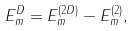Convert formula to latex. <formula><loc_0><loc_0><loc_500><loc_500>E ^ { D } _ { m } = E ^ { ( 2 D ) } _ { m } - E ^ { ( 2 ) } _ { m } ,</formula> 